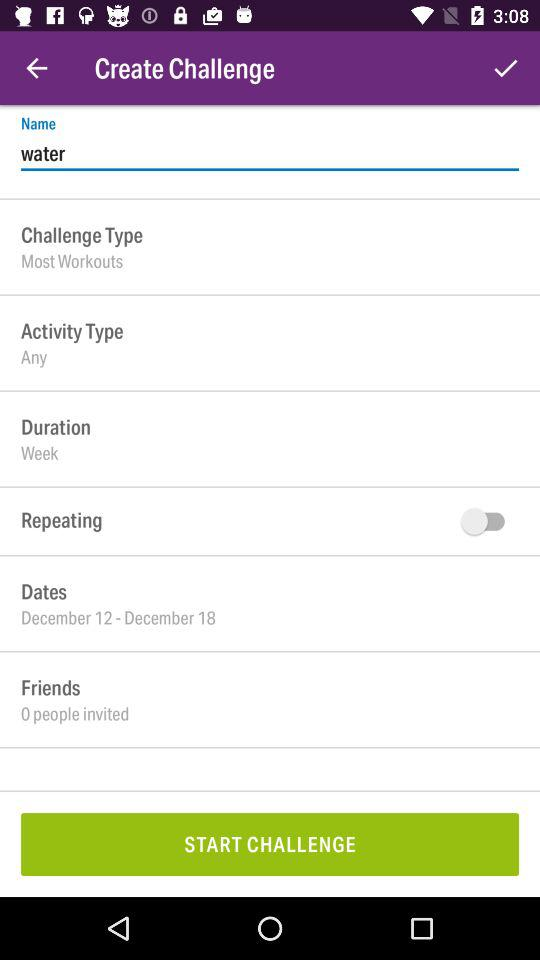How many people are invited to the challenge?
Answer the question using a single word or phrase. 0 